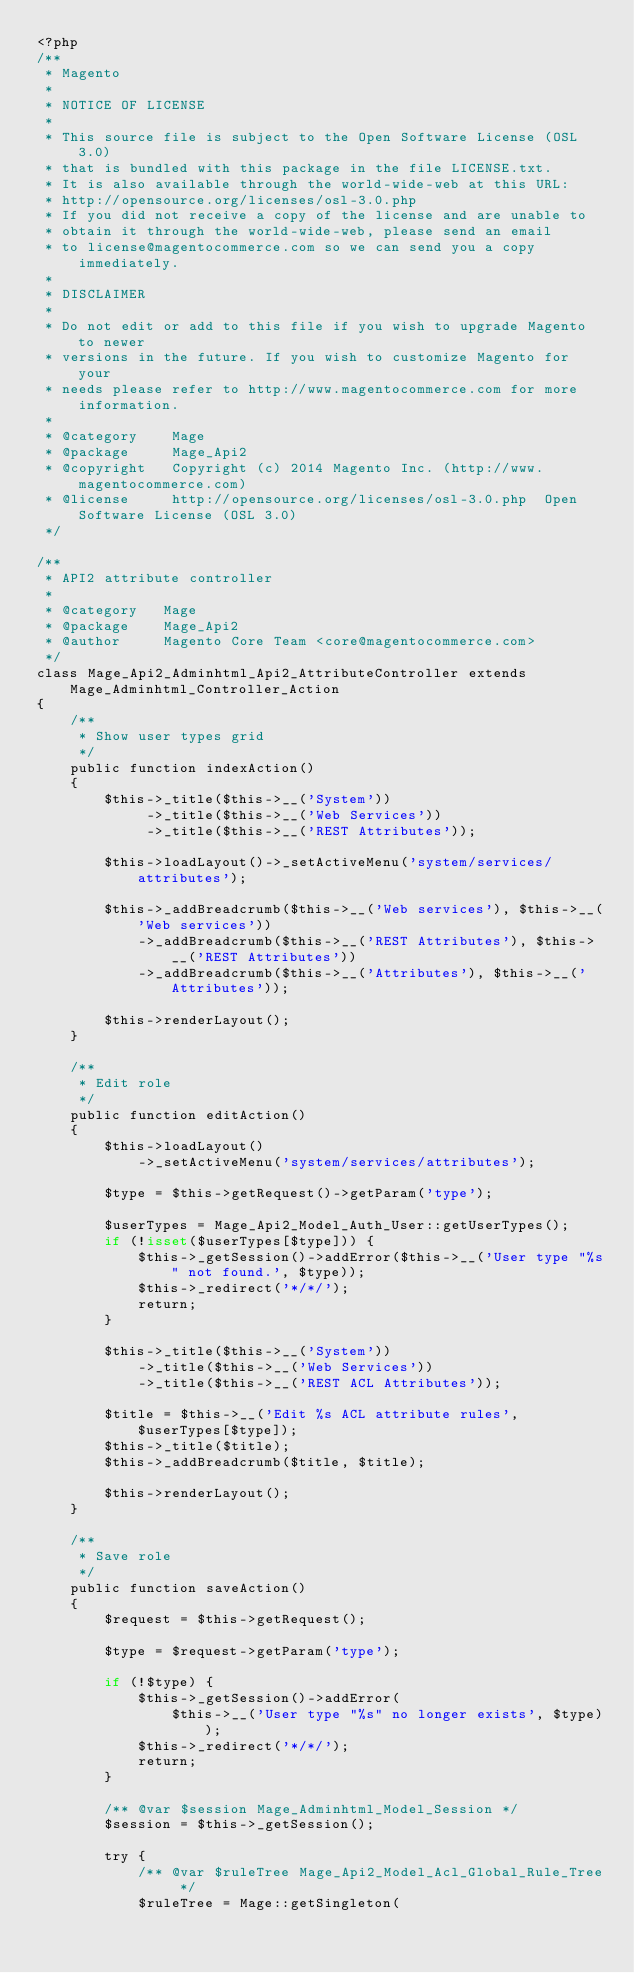Convert code to text. <code><loc_0><loc_0><loc_500><loc_500><_PHP_><?php
/**
 * Magento
 *
 * NOTICE OF LICENSE
 *
 * This source file is subject to the Open Software License (OSL 3.0)
 * that is bundled with this package in the file LICENSE.txt.
 * It is also available through the world-wide-web at this URL:
 * http://opensource.org/licenses/osl-3.0.php
 * If you did not receive a copy of the license and are unable to
 * obtain it through the world-wide-web, please send an email
 * to license@magentocommerce.com so we can send you a copy immediately.
 *
 * DISCLAIMER
 *
 * Do not edit or add to this file if you wish to upgrade Magento to newer
 * versions in the future. If you wish to customize Magento for your
 * needs please refer to http://www.magentocommerce.com for more information.
 *
 * @category    Mage
 * @package     Mage_Api2
 * @copyright   Copyright (c) 2014 Magento Inc. (http://www.magentocommerce.com)
 * @license     http://opensource.org/licenses/osl-3.0.php  Open Software License (OSL 3.0)
 */

/**
 * API2 attribute controller
 *
 * @category   Mage
 * @package    Mage_Api2
 * @author     Magento Core Team <core@magentocommerce.com>
 */
class Mage_Api2_Adminhtml_Api2_AttributeController extends Mage_Adminhtml_Controller_Action
{
    /**
     * Show user types grid
     */
    public function indexAction()
    {
        $this->_title($this->__('System'))
             ->_title($this->__('Web Services'))
             ->_title($this->__('REST Attributes'));

        $this->loadLayout()->_setActiveMenu('system/services/attributes');

        $this->_addBreadcrumb($this->__('Web services'), $this->__('Web services'))
            ->_addBreadcrumb($this->__('REST Attributes'), $this->__('REST Attributes'))
            ->_addBreadcrumb($this->__('Attributes'), $this->__('Attributes'));

        $this->renderLayout();
    }

    /**
     * Edit role
     */
    public function editAction()
    {
        $this->loadLayout()
            ->_setActiveMenu('system/services/attributes');

        $type = $this->getRequest()->getParam('type');

        $userTypes = Mage_Api2_Model_Auth_User::getUserTypes();
        if (!isset($userTypes[$type])) {
            $this->_getSession()->addError($this->__('User type "%s" not found.', $type));
            $this->_redirect('*/*/');
            return;
        }

        $this->_title($this->__('System'))
            ->_title($this->__('Web Services'))
            ->_title($this->__('REST ACL Attributes'));

        $title = $this->__('Edit %s ACL attribute rules', $userTypes[$type]);
        $this->_title($title);
        $this->_addBreadcrumb($title, $title);

        $this->renderLayout();
    }

    /**
     * Save role
     */
    public function saveAction()
    {
        $request = $this->getRequest();

        $type = $request->getParam('type');

        if (!$type) {
            $this->_getSession()->addError(
                $this->__('User type "%s" no longer exists', $type));
            $this->_redirect('*/*/');
            return;
        }

        /** @var $session Mage_Adminhtml_Model_Session */
        $session = $this->_getSession();

        try {
            /** @var $ruleTree Mage_Api2_Model_Acl_Global_Rule_Tree */
            $ruleTree = Mage::getSingleton(</code> 